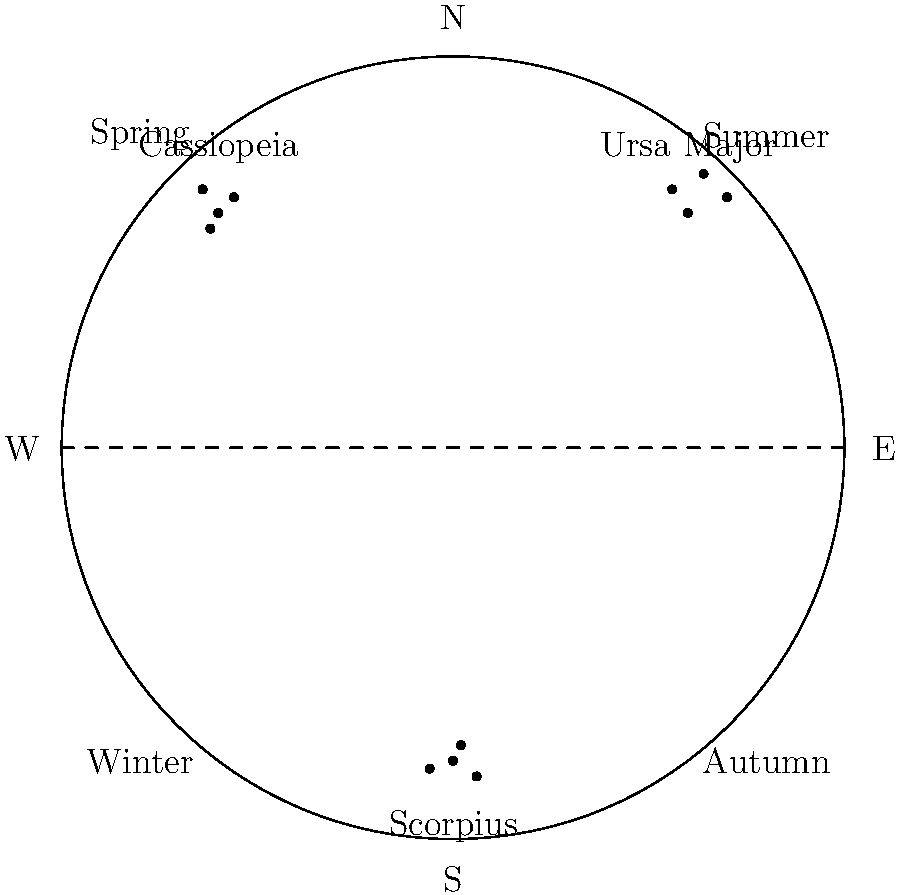In Korean literature, celestial themes often appear. As a book club organizer, you want to discuss how different constellations visible in various seasons might influence Korean authors. Based on the diagram, which constellation is prominently visible during the summer months in the Northern Hemisphere? To answer this question, we need to analyze the diagram and understand how the visibility of constellations changes with seasons:

1. The diagram represents the celestial sphere as seen from the Northern Hemisphere.
2. The horizon line divides the visible sky (above) from the non-visible part (below).
3. The diagram is labeled with cardinal directions (N, S, E, W) and seasons.
4. Three constellations are shown: Ursa Major, Cassiopeia, and Scorpius.
5. In the Northern Hemisphere, constellations near the North celestial pole (near "N" in the diagram) are circumpolar and visible year-round.
6. Constellations in the southern part of the sky change with seasons.
7. The "Summer" label is in the upper right quadrant of the diagram.
8. Scorpius is shown in the lower part of the diagram, near the "S" label.
9. In summer, the Sun is high in the northern sky, so southern constellations like Scorpius become visible at night.

Therefore, among the constellations shown, Scorpius is the one prominently visible during summer months in the Northern Hemisphere.
Answer: Scorpius 